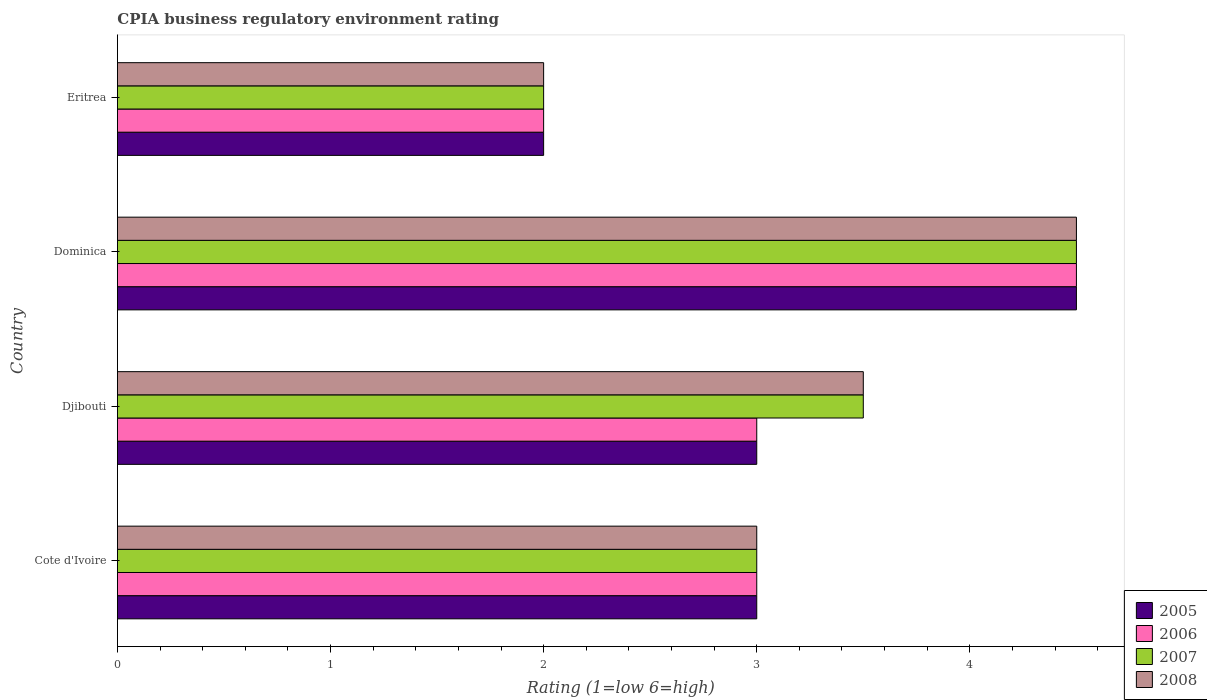Are the number of bars per tick equal to the number of legend labels?
Keep it short and to the point. Yes. What is the label of the 4th group of bars from the top?
Make the answer very short. Cote d'Ivoire. In how many cases, is the number of bars for a given country not equal to the number of legend labels?
Give a very brief answer. 0. Across all countries, what is the maximum CPIA rating in 2008?
Your answer should be very brief. 4.5. In which country was the CPIA rating in 2006 maximum?
Provide a succinct answer. Dominica. In which country was the CPIA rating in 2007 minimum?
Your response must be concise. Eritrea. What is the total CPIA rating in 2007 in the graph?
Ensure brevity in your answer.  13. What is the difference between the CPIA rating in 2006 in Dominica and that in Eritrea?
Provide a short and direct response. 2.5. What is the average CPIA rating in 2007 per country?
Keep it short and to the point. 3.25. In how many countries, is the CPIA rating in 2007 greater than 1.8 ?
Give a very brief answer. 4. What is the ratio of the CPIA rating in 2005 in Cote d'Ivoire to that in Dominica?
Your answer should be compact. 0.67. Is the CPIA rating in 2007 in Cote d'Ivoire less than that in Djibouti?
Your answer should be compact. Yes. What is the difference between the highest and the second highest CPIA rating in 2005?
Your answer should be very brief. 1.5. In how many countries, is the CPIA rating in 2005 greater than the average CPIA rating in 2005 taken over all countries?
Give a very brief answer. 1. What does the 2nd bar from the top in Eritrea represents?
Make the answer very short. 2007. How many bars are there?
Your answer should be compact. 16. Are all the bars in the graph horizontal?
Offer a very short reply. Yes. How many countries are there in the graph?
Provide a succinct answer. 4. What is the difference between two consecutive major ticks on the X-axis?
Your response must be concise. 1. Are the values on the major ticks of X-axis written in scientific E-notation?
Offer a very short reply. No. Does the graph contain any zero values?
Provide a succinct answer. No. How are the legend labels stacked?
Provide a succinct answer. Vertical. What is the title of the graph?
Ensure brevity in your answer.  CPIA business regulatory environment rating. Does "2015" appear as one of the legend labels in the graph?
Provide a short and direct response. No. What is the label or title of the X-axis?
Provide a succinct answer. Rating (1=low 6=high). What is the label or title of the Y-axis?
Provide a short and direct response. Country. What is the Rating (1=low 6=high) of 2007 in Cote d'Ivoire?
Your answer should be very brief. 3. What is the Rating (1=low 6=high) of 2008 in Cote d'Ivoire?
Provide a succinct answer. 3. What is the Rating (1=low 6=high) in 2008 in Djibouti?
Make the answer very short. 3.5. What is the Rating (1=low 6=high) in 2005 in Dominica?
Give a very brief answer. 4.5. What is the Rating (1=low 6=high) of 2006 in Dominica?
Ensure brevity in your answer.  4.5. What is the Rating (1=low 6=high) of 2006 in Eritrea?
Make the answer very short. 2. What is the Rating (1=low 6=high) in 2007 in Eritrea?
Give a very brief answer. 2. Across all countries, what is the maximum Rating (1=low 6=high) of 2005?
Make the answer very short. 4.5. Across all countries, what is the maximum Rating (1=low 6=high) in 2006?
Your answer should be compact. 4.5. Across all countries, what is the maximum Rating (1=low 6=high) in 2007?
Give a very brief answer. 4.5. Across all countries, what is the minimum Rating (1=low 6=high) in 2005?
Give a very brief answer. 2. Across all countries, what is the minimum Rating (1=low 6=high) of 2006?
Give a very brief answer. 2. What is the total Rating (1=low 6=high) of 2005 in the graph?
Make the answer very short. 12.5. What is the difference between the Rating (1=low 6=high) of 2006 in Cote d'Ivoire and that in Djibouti?
Provide a short and direct response. 0. What is the difference between the Rating (1=low 6=high) of 2008 in Cote d'Ivoire and that in Djibouti?
Provide a succinct answer. -0.5. What is the difference between the Rating (1=low 6=high) in 2008 in Cote d'Ivoire and that in Dominica?
Ensure brevity in your answer.  -1.5. What is the difference between the Rating (1=low 6=high) in 2005 in Djibouti and that in Dominica?
Your answer should be very brief. -1.5. What is the difference between the Rating (1=low 6=high) of 2007 in Djibouti and that in Dominica?
Ensure brevity in your answer.  -1. What is the difference between the Rating (1=low 6=high) in 2005 in Djibouti and that in Eritrea?
Give a very brief answer. 1. What is the difference between the Rating (1=low 6=high) of 2005 in Dominica and that in Eritrea?
Keep it short and to the point. 2.5. What is the difference between the Rating (1=low 6=high) of 2006 in Dominica and that in Eritrea?
Provide a succinct answer. 2.5. What is the difference between the Rating (1=low 6=high) in 2008 in Dominica and that in Eritrea?
Offer a very short reply. 2.5. What is the difference between the Rating (1=low 6=high) in 2006 in Cote d'Ivoire and the Rating (1=low 6=high) in 2007 in Djibouti?
Offer a very short reply. -0.5. What is the difference between the Rating (1=low 6=high) of 2006 in Cote d'Ivoire and the Rating (1=low 6=high) of 2008 in Djibouti?
Offer a very short reply. -0.5. What is the difference between the Rating (1=low 6=high) of 2007 in Cote d'Ivoire and the Rating (1=low 6=high) of 2008 in Djibouti?
Ensure brevity in your answer.  -0.5. What is the difference between the Rating (1=low 6=high) of 2005 in Cote d'Ivoire and the Rating (1=low 6=high) of 2006 in Dominica?
Make the answer very short. -1.5. What is the difference between the Rating (1=low 6=high) in 2005 in Cote d'Ivoire and the Rating (1=low 6=high) in 2008 in Dominica?
Make the answer very short. -1.5. What is the difference between the Rating (1=low 6=high) of 2006 in Cote d'Ivoire and the Rating (1=low 6=high) of 2007 in Dominica?
Keep it short and to the point. -1.5. What is the difference between the Rating (1=low 6=high) in 2005 in Cote d'Ivoire and the Rating (1=low 6=high) in 2006 in Eritrea?
Provide a short and direct response. 1. What is the difference between the Rating (1=low 6=high) of 2005 in Cote d'Ivoire and the Rating (1=low 6=high) of 2007 in Eritrea?
Your answer should be very brief. 1. What is the difference between the Rating (1=low 6=high) in 2006 in Cote d'Ivoire and the Rating (1=low 6=high) in 2007 in Eritrea?
Offer a very short reply. 1. What is the difference between the Rating (1=low 6=high) in 2005 in Djibouti and the Rating (1=low 6=high) in 2006 in Dominica?
Provide a short and direct response. -1.5. What is the difference between the Rating (1=low 6=high) in 2005 in Djibouti and the Rating (1=low 6=high) in 2007 in Dominica?
Provide a succinct answer. -1.5. What is the difference between the Rating (1=low 6=high) of 2005 in Djibouti and the Rating (1=low 6=high) of 2008 in Dominica?
Your response must be concise. -1.5. What is the difference between the Rating (1=low 6=high) in 2006 in Djibouti and the Rating (1=low 6=high) in 2008 in Dominica?
Your answer should be very brief. -1.5. What is the difference between the Rating (1=low 6=high) of 2005 in Dominica and the Rating (1=low 6=high) of 2006 in Eritrea?
Offer a very short reply. 2.5. What is the difference between the Rating (1=low 6=high) in 2006 in Dominica and the Rating (1=low 6=high) in 2007 in Eritrea?
Keep it short and to the point. 2.5. What is the average Rating (1=low 6=high) in 2005 per country?
Make the answer very short. 3.12. What is the average Rating (1=low 6=high) of 2006 per country?
Keep it short and to the point. 3.12. What is the average Rating (1=low 6=high) of 2008 per country?
Make the answer very short. 3.25. What is the difference between the Rating (1=low 6=high) in 2005 and Rating (1=low 6=high) in 2007 in Cote d'Ivoire?
Make the answer very short. 0. What is the difference between the Rating (1=low 6=high) of 2006 and Rating (1=low 6=high) of 2008 in Cote d'Ivoire?
Give a very brief answer. 0. What is the difference between the Rating (1=low 6=high) in 2005 and Rating (1=low 6=high) in 2006 in Djibouti?
Your answer should be very brief. 0. What is the difference between the Rating (1=low 6=high) in 2005 and Rating (1=low 6=high) in 2007 in Djibouti?
Offer a terse response. -0.5. What is the difference between the Rating (1=low 6=high) in 2005 and Rating (1=low 6=high) in 2008 in Dominica?
Give a very brief answer. 0. What is the difference between the Rating (1=low 6=high) in 2006 and Rating (1=low 6=high) in 2008 in Dominica?
Offer a terse response. 0. What is the difference between the Rating (1=low 6=high) of 2005 and Rating (1=low 6=high) of 2008 in Eritrea?
Your answer should be compact. 0. What is the difference between the Rating (1=low 6=high) in 2006 and Rating (1=low 6=high) in 2007 in Eritrea?
Your answer should be very brief. 0. What is the difference between the Rating (1=low 6=high) of 2006 and Rating (1=low 6=high) of 2008 in Eritrea?
Give a very brief answer. 0. What is the difference between the Rating (1=low 6=high) of 2007 and Rating (1=low 6=high) of 2008 in Eritrea?
Offer a terse response. 0. What is the ratio of the Rating (1=low 6=high) of 2005 in Cote d'Ivoire to that in Djibouti?
Provide a succinct answer. 1. What is the ratio of the Rating (1=low 6=high) in 2006 in Cote d'Ivoire to that in Djibouti?
Offer a terse response. 1. What is the ratio of the Rating (1=low 6=high) in 2008 in Cote d'Ivoire to that in Djibouti?
Make the answer very short. 0.86. What is the ratio of the Rating (1=low 6=high) in 2006 in Cote d'Ivoire to that in Dominica?
Keep it short and to the point. 0.67. What is the ratio of the Rating (1=low 6=high) of 2007 in Cote d'Ivoire to that in Dominica?
Your answer should be very brief. 0.67. What is the ratio of the Rating (1=low 6=high) in 2008 in Cote d'Ivoire to that in Eritrea?
Ensure brevity in your answer.  1.5. What is the ratio of the Rating (1=low 6=high) of 2005 in Djibouti to that in Dominica?
Your answer should be very brief. 0.67. What is the ratio of the Rating (1=low 6=high) of 2005 in Djibouti to that in Eritrea?
Provide a short and direct response. 1.5. What is the ratio of the Rating (1=low 6=high) of 2006 in Djibouti to that in Eritrea?
Give a very brief answer. 1.5. What is the ratio of the Rating (1=low 6=high) of 2007 in Djibouti to that in Eritrea?
Offer a terse response. 1.75. What is the ratio of the Rating (1=low 6=high) in 2008 in Djibouti to that in Eritrea?
Provide a short and direct response. 1.75. What is the ratio of the Rating (1=low 6=high) in 2005 in Dominica to that in Eritrea?
Offer a very short reply. 2.25. What is the ratio of the Rating (1=low 6=high) in 2006 in Dominica to that in Eritrea?
Keep it short and to the point. 2.25. What is the ratio of the Rating (1=low 6=high) in 2007 in Dominica to that in Eritrea?
Give a very brief answer. 2.25. What is the ratio of the Rating (1=low 6=high) of 2008 in Dominica to that in Eritrea?
Provide a short and direct response. 2.25. What is the difference between the highest and the second highest Rating (1=low 6=high) in 2006?
Ensure brevity in your answer.  1.5. What is the difference between the highest and the second highest Rating (1=low 6=high) in 2007?
Provide a short and direct response. 1. What is the difference between the highest and the lowest Rating (1=low 6=high) of 2008?
Provide a succinct answer. 2.5. 